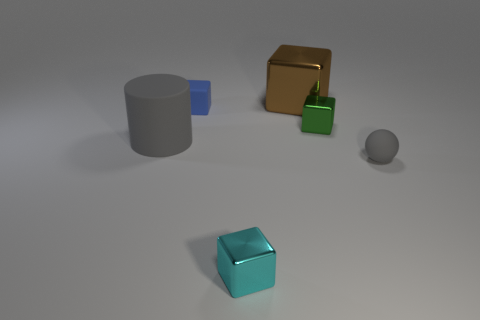Add 4 green things. How many objects exist? 10 Subtract all cylinders. How many objects are left? 5 Subtract all blue matte spheres. Subtract all large brown metal objects. How many objects are left? 5 Add 2 tiny rubber blocks. How many tiny rubber blocks are left? 3 Add 4 big gray matte objects. How many big gray matte objects exist? 5 Subtract 0 cyan balls. How many objects are left? 6 